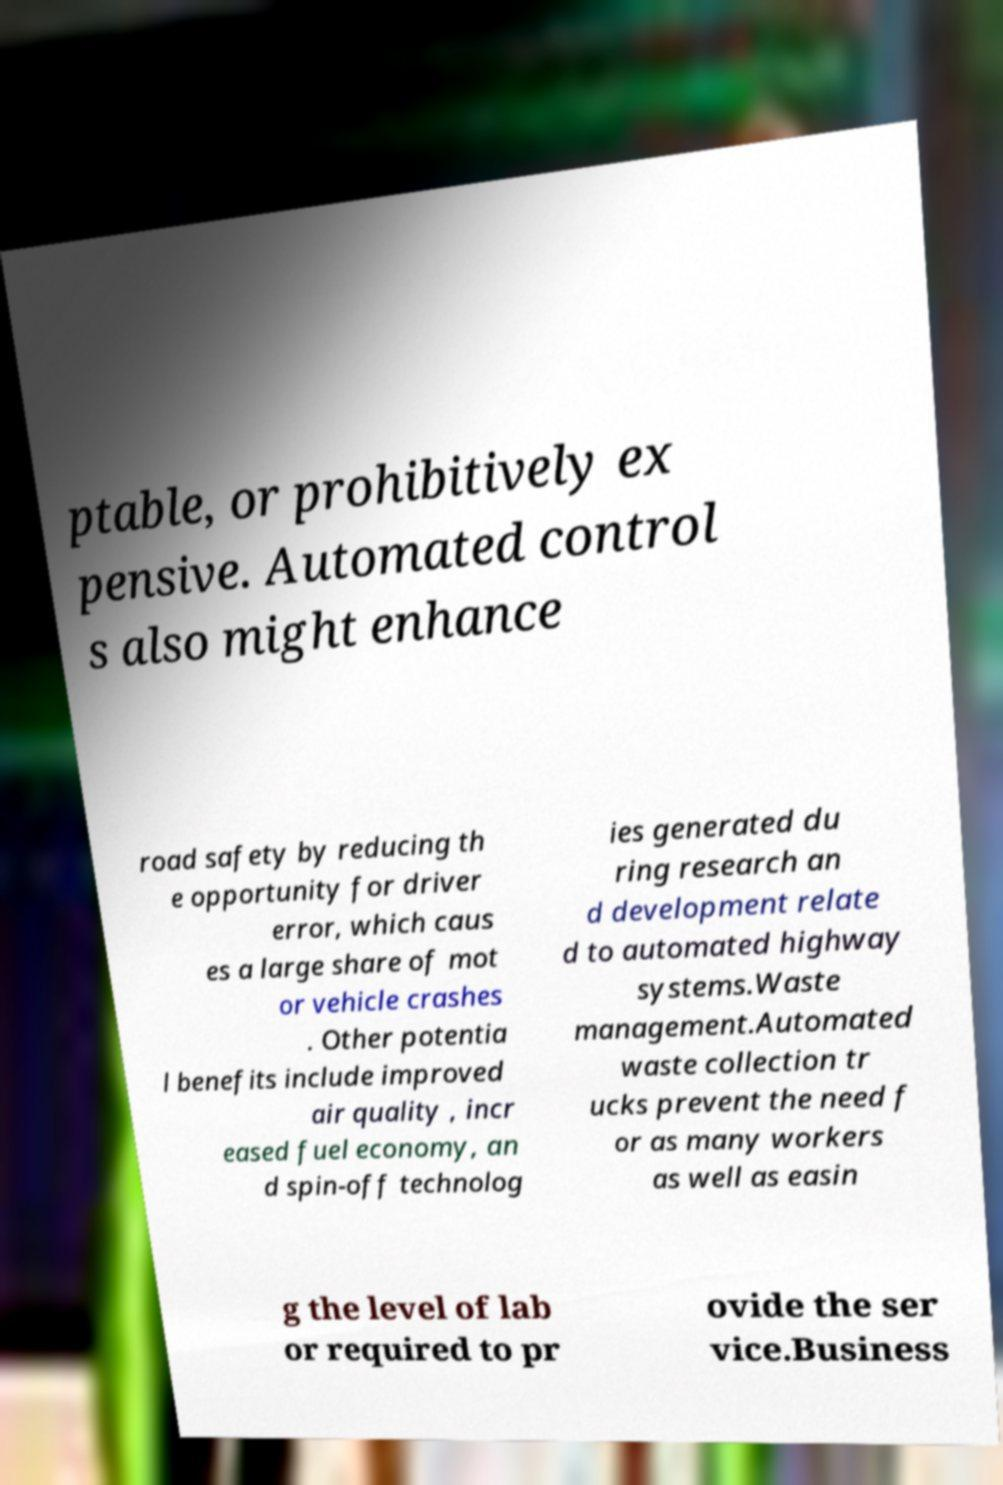For documentation purposes, I need the text within this image transcribed. Could you provide that? ptable, or prohibitively ex pensive. Automated control s also might enhance road safety by reducing th e opportunity for driver error, which caus es a large share of mot or vehicle crashes . Other potentia l benefits include improved air quality , incr eased fuel economy, an d spin-off technolog ies generated du ring research an d development relate d to automated highway systems.Waste management.Automated waste collection tr ucks prevent the need f or as many workers as well as easin g the level of lab or required to pr ovide the ser vice.Business 